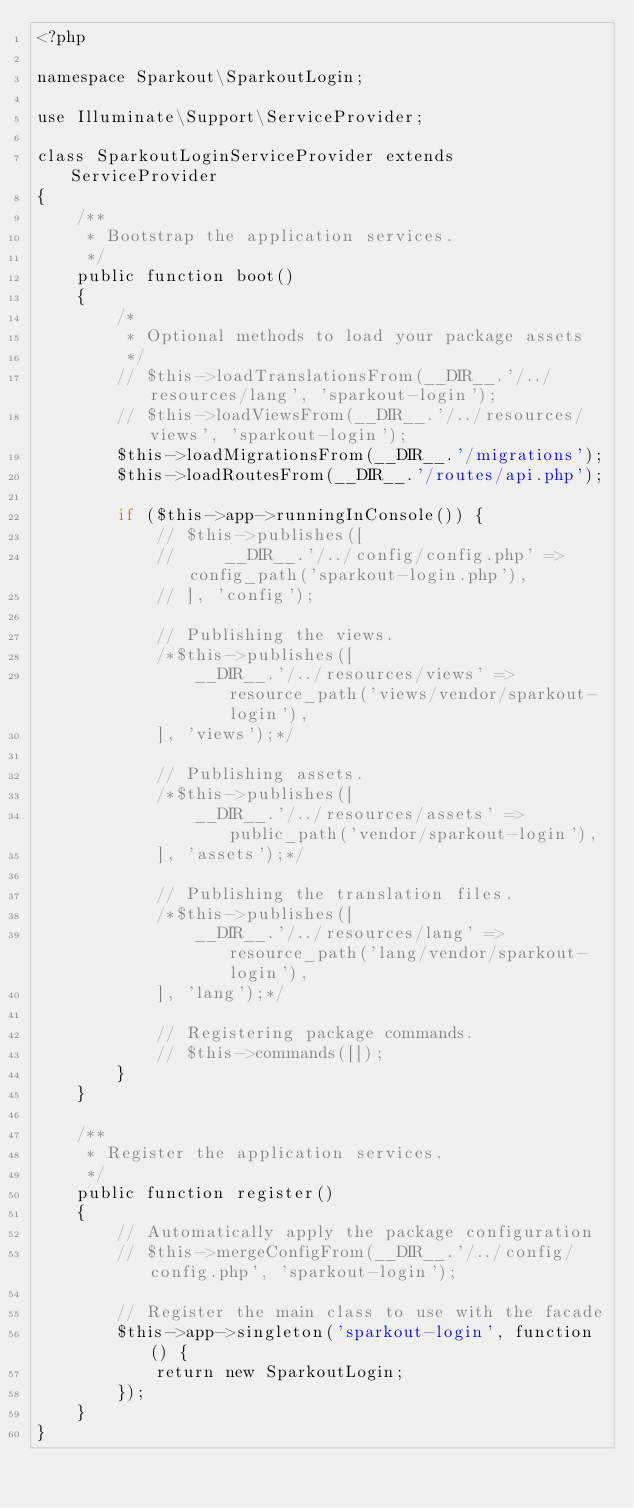<code> <loc_0><loc_0><loc_500><loc_500><_PHP_><?php

namespace Sparkout\SparkoutLogin;

use Illuminate\Support\ServiceProvider;

class SparkoutLoginServiceProvider extends ServiceProvider
{
    /**
     * Bootstrap the application services.
     */
    public function boot()
    {
        /*
         * Optional methods to load your package assets
         */
        // $this->loadTranslationsFrom(__DIR__.'/../resources/lang', 'sparkout-login');
        // $this->loadViewsFrom(__DIR__.'/../resources/views', 'sparkout-login');
        $this->loadMigrationsFrom(__DIR__.'/migrations');
        $this->loadRoutesFrom(__DIR__.'/routes/api.php');

        if ($this->app->runningInConsole()) {
            // $this->publishes([
            //     __DIR__.'/../config/config.php' => config_path('sparkout-login.php'),
            // ], 'config');

            // Publishing the views.
            /*$this->publishes([
                __DIR__.'/../resources/views' => resource_path('views/vendor/sparkout-login'),
            ], 'views');*/

            // Publishing assets.
            /*$this->publishes([
                __DIR__.'/../resources/assets' => public_path('vendor/sparkout-login'),
            ], 'assets');*/

            // Publishing the translation files.
            /*$this->publishes([
                __DIR__.'/../resources/lang' => resource_path('lang/vendor/sparkout-login'),
            ], 'lang');*/

            // Registering package commands.
            // $this->commands([]);
        }
    }

    /**
     * Register the application services.
     */
    public function register()
    {
        // Automatically apply the package configuration
        // $this->mergeConfigFrom(__DIR__.'/../config/config.php', 'sparkout-login');

        // Register the main class to use with the facade
        $this->app->singleton('sparkout-login', function () {
            return new SparkoutLogin;
        });
    }
}
</code> 